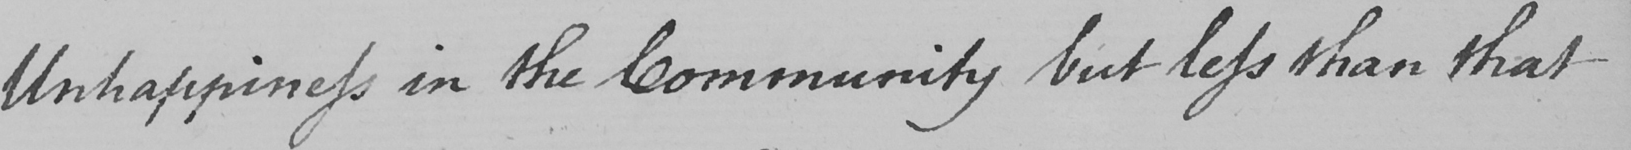Can you tell me what this handwritten text says? Unhappiness in the Community but less than that 